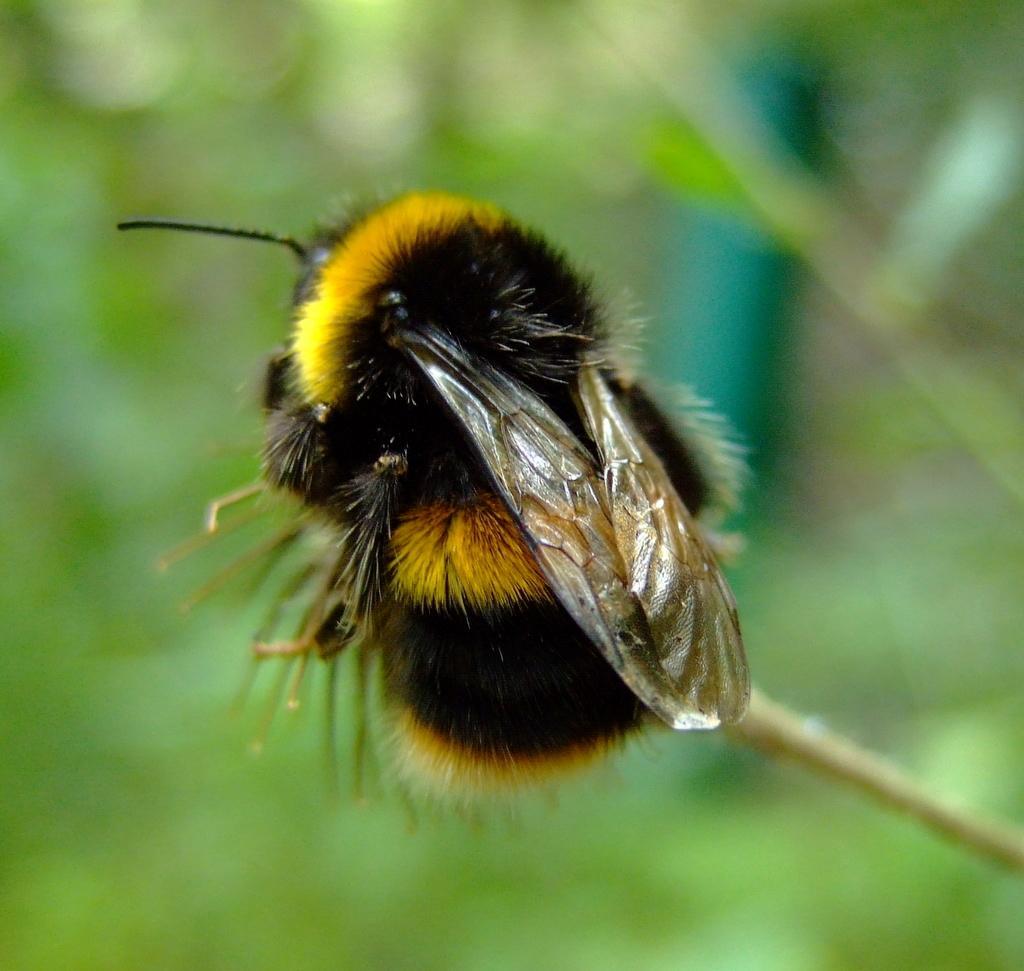Can you describe this image briefly? This is zoom-in picture of an insect which is in black and yellow color. 